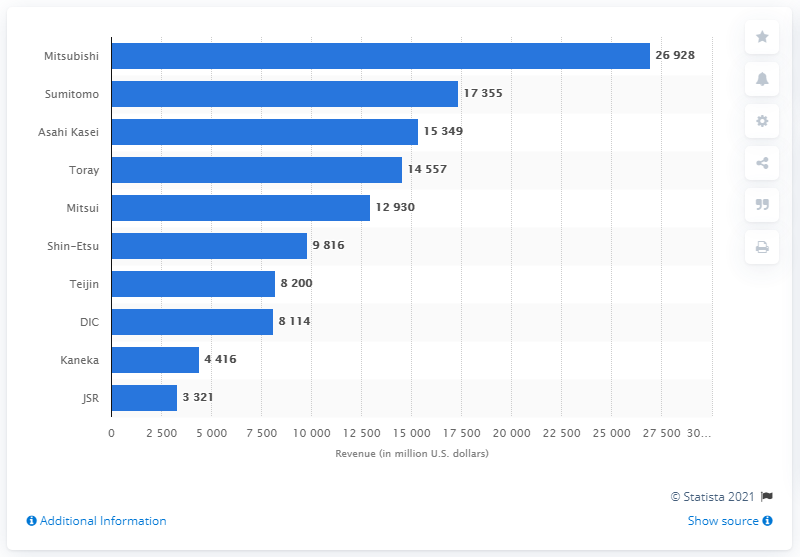Outline some significant characteristics in this image. In 2009, Asahi Kasei's total revenue was 15,349 million dollars. 